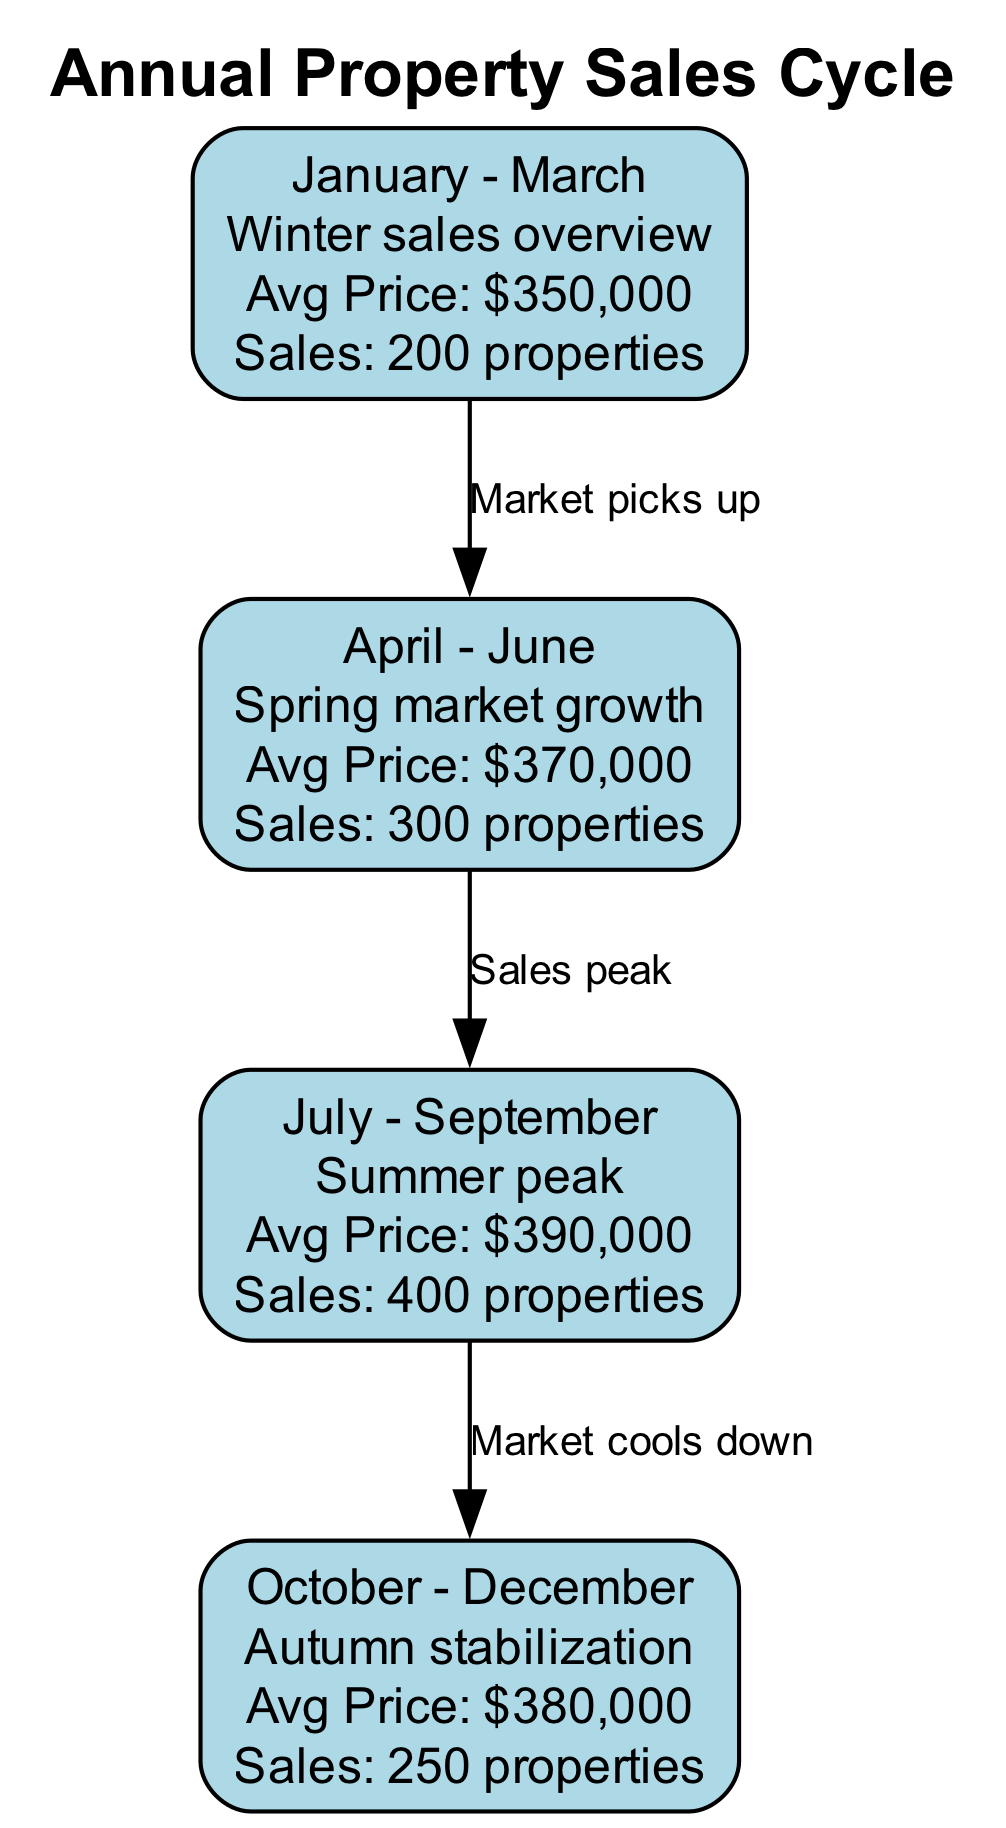What is the average price in July - September? According to the diagram, the average price for the period from July to September is displayed as "$390,000."
Answer: $390,000 How many properties were sold in April - June? The sales volume for the period from April to June is shown as "300 properties."
Answer: 300 properties What is the relationship between January - March and April - June? The diagram indicates an edge labeled "Market picks up" from January - March to April - June, signaling an increase in market activity.
Answer: Market picks up What is the sales volume during the Summer peak? The diagram specifies that the sales volume during the peak summer season (July to September) is "400 properties."
Answer: 400 properties In which quarter is the average price the highest? By examining the average prices provided for each quarter, July - September has the highest average price of "$390,000."
Answer: July - September How many nodes are there in the diagram? The diagram lists 4 distinct periods, which correspond to the 4 nodes present in the visual representation.
Answer: 4 What happens to the market between July - September and October - December? The edge between these two nodes is labeled "Market cools down," indicating a decrease in market activity moving from summer to autumn.
Answer: Market cools down What is the average price for the Winter sales overview? The diagram shows that the average price during January to March is "$350,000."
Answer: $350,000 Which quarter has the lowest sales volume? Based on the sales volume data, the period from October to December has a sales volume of "250 properties," which is the lowest among all quarters.
Answer: October - December 